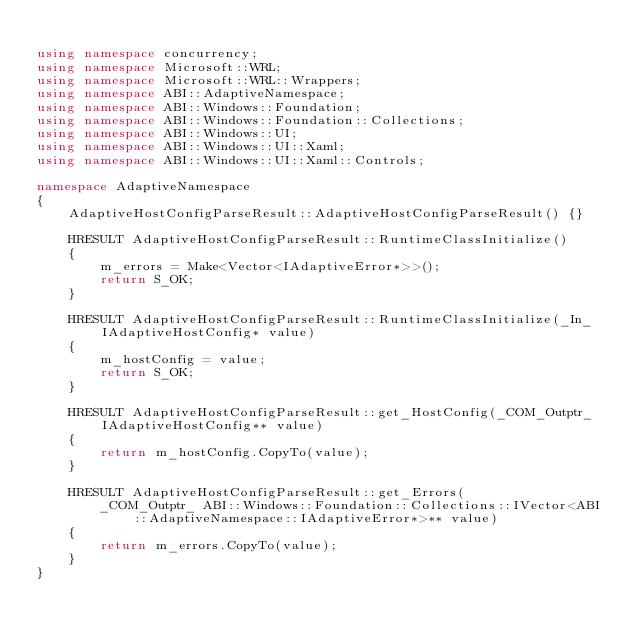Convert code to text. <code><loc_0><loc_0><loc_500><loc_500><_C++_>
using namespace concurrency;
using namespace Microsoft::WRL;
using namespace Microsoft::WRL::Wrappers;
using namespace ABI::AdaptiveNamespace;
using namespace ABI::Windows::Foundation;
using namespace ABI::Windows::Foundation::Collections;
using namespace ABI::Windows::UI;
using namespace ABI::Windows::UI::Xaml;
using namespace ABI::Windows::UI::Xaml::Controls;

namespace AdaptiveNamespace
{
    AdaptiveHostConfigParseResult::AdaptiveHostConfigParseResult() {}

    HRESULT AdaptiveHostConfigParseResult::RuntimeClassInitialize()
    {
        m_errors = Make<Vector<IAdaptiveError*>>();
        return S_OK;
    }

    HRESULT AdaptiveHostConfigParseResult::RuntimeClassInitialize(_In_ IAdaptiveHostConfig* value)
    {
        m_hostConfig = value;
        return S_OK;
    }

    HRESULT AdaptiveHostConfigParseResult::get_HostConfig(_COM_Outptr_ IAdaptiveHostConfig** value)
    {
        return m_hostConfig.CopyTo(value);
    }

    HRESULT AdaptiveHostConfigParseResult::get_Errors(
        _COM_Outptr_ ABI::Windows::Foundation::Collections::IVector<ABI::AdaptiveNamespace::IAdaptiveError*>** value)
    {
        return m_errors.CopyTo(value);
    }
}
</code> 